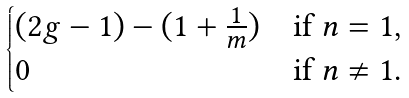Convert formula to latex. <formula><loc_0><loc_0><loc_500><loc_500>\begin{cases} ( 2 g - 1 ) - ( 1 + \frac { 1 } { m } ) & \text {if $n=1$,} \\ 0 & \text {if $n \ne 1$.} \end{cases}</formula> 